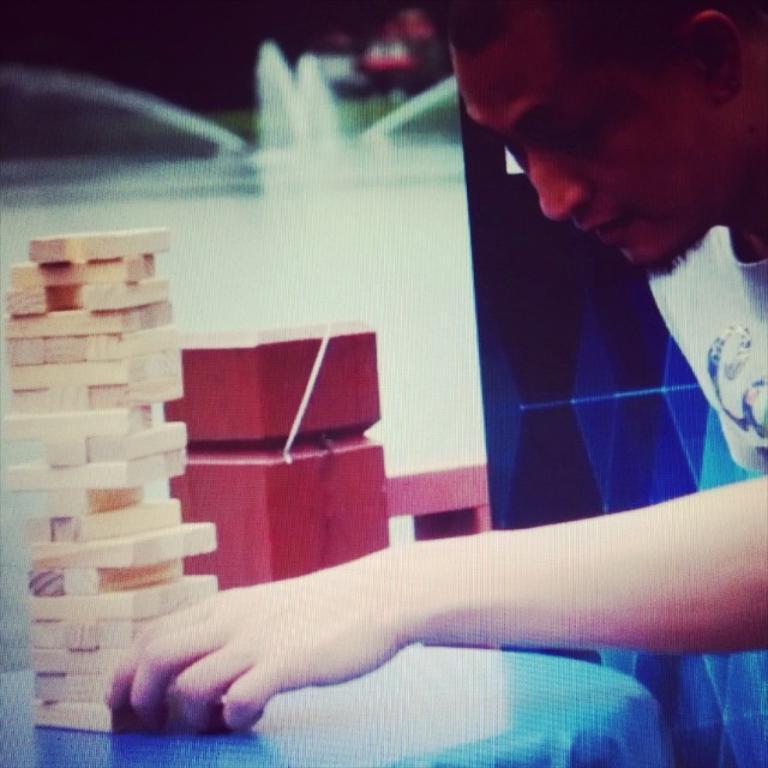In one or two sentences, can you explain what this image depicts? In this image there is a table. On the table there are wooden blocks. It is called as jenga. To the right there is a person. In the background there is a water fountain. 